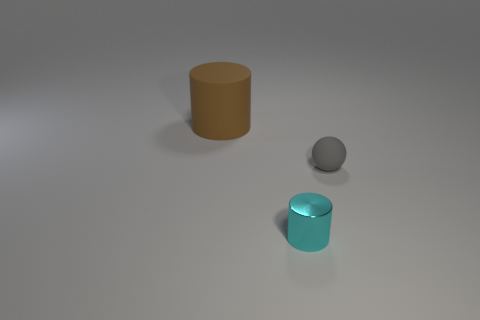Is there anything else that has the same material as the small cylinder?
Ensure brevity in your answer.  No. The big rubber cylinder is what color?
Provide a succinct answer. Brown. There is another gray thing that is made of the same material as the large object; what is its size?
Your answer should be very brief. Small. There is a large cylinder that is the same material as the gray ball; what color is it?
Give a very brief answer. Brown. Are there any objects of the same size as the brown cylinder?
Your answer should be compact. No. There is a big thing that is the same shape as the tiny metal object; what is its material?
Your response must be concise. Rubber. There is a cyan shiny thing that is the same size as the gray object; what is its shape?
Offer a terse response. Cylinder. Is there a shiny object of the same shape as the small gray matte thing?
Provide a succinct answer. No. There is a small object that is behind the cylinder that is on the right side of the brown cylinder; what shape is it?
Give a very brief answer. Sphere. What is the shape of the brown matte object?
Ensure brevity in your answer.  Cylinder. 